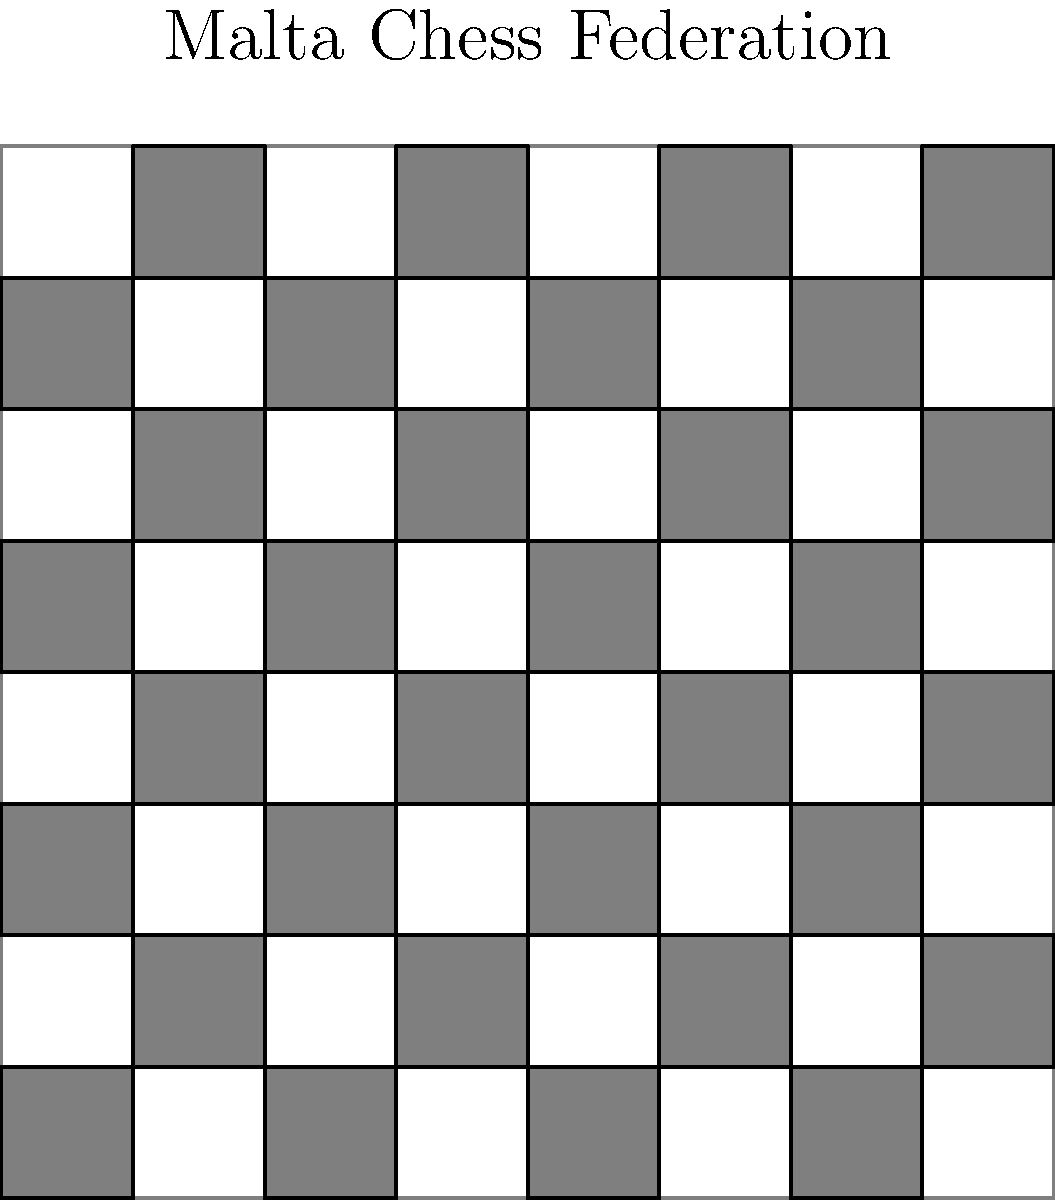The Malta Chess Federation is organizing a tournament and wants to explore the symmetry group of a standard 8x8 chessboard. How many elements are in the symmetry group of a chessboard, considering rotations and reflections? Let's approach this step-by-step:

1) First, let's consider the rotational symmetries:
   - The chessboard can be rotated by 0°, 90°, 180°, and 270°.
   - This gives us 4 rotational symmetries.

2) Now, let's consider the reflection symmetries:
   - The chessboard can be reflected across its vertical center line.
   - It can be reflected across its horizontal center line.
   - It can be reflected across each of its two diagonals.
   - This gives us 4 reflection symmetries.

3) The identity transformation (doing nothing) is also considered a symmetry.

4) However, we've already counted the identity transformation in our rotational symmetries (0° rotation).

5) Therefore, the total number of symmetries is:
   $4 \text{ (rotations)} + 4 \text{ (reflections)} = 8$

6) This group of 8 symmetries is known as the dihedral group $D_4$.

7) We can verify this by listing all the symmetries:
   - Identity
   - 90° rotation
   - 180° rotation
   - 270° rotation
   - Vertical reflection
   - Horizontal reflection
   - Diagonal reflection (top-left to bottom-right)
   - Diagonal reflection (top-right to bottom-left)

Thus, the symmetry group of a chessboard has 8 elements.
Answer: 8 